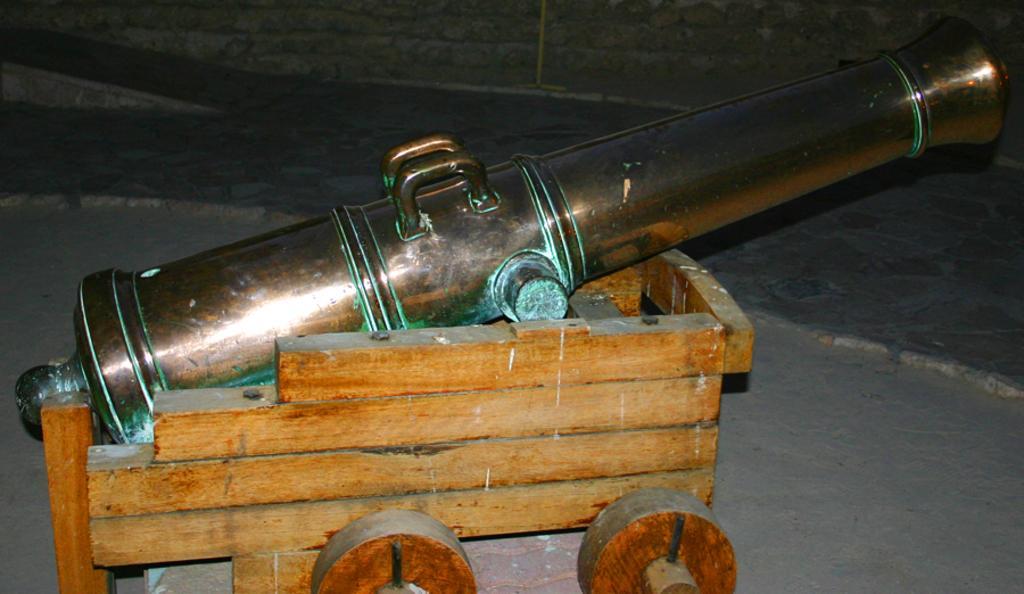Please provide a concise description of this image. In this image I see a cannon which is on the wooden cart and I see the ground. 